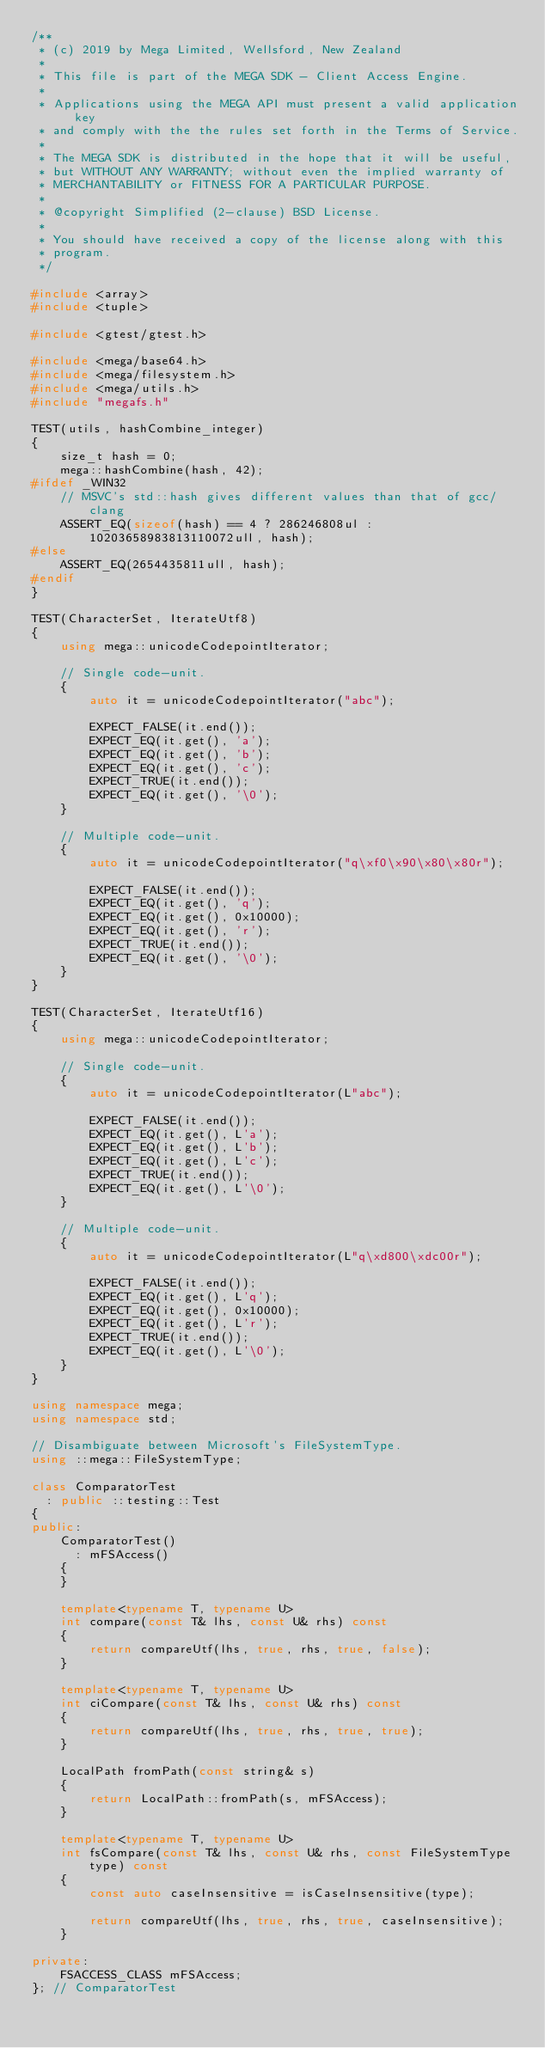Convert code to text. <code><loc_0><loc_0><loc_500><loc_500><_C++_>/**
 * (c) 2019 by Mega Limited, Wellsford, New Zealand
 *
 * This file is part of the MEGA SDK - Client Access Engine.
 *
 * Applications using the MEGA API must present a valid application key
 * and comply with the the rules set forth in the Terms of Service.
 *
 * The MEGA SDK is distributed in the hope that it will be useful,
 * but WITHOUT ANY WARRANTY; without even the implied warranty of
 * MERCHANTABILITY or FITNESS FOR A PARTICULAR PURPOSE.
 *
 * @copyright Simplified (2-clause) BSD License.
 *
 * You should have received a copy of the license along with this
 * program.
 */

#include <array>
#include <tuple>

#include <gtest/gtest.h>

#include <mega/base64.h>
#include <mega/filesystem.h>
#include <mega/utils.h>
#include "megafs.h"

TEST(utils, hashCombine_integer)
{
    size_t hash = 0;
    mega::hashCombine(hash, 42);
#ifdef _WIN32
    // MSVC's std::hash gives different values than that of gcc/clang
    ASSERT_EQ(sizeof(hash) == 4 ? 286246808ul : 10203658983813110072ull, hash);
#else
    ASSERT_EQ(2654435811ull, hash);
#endif
}

TEST(CharacterSet, IterateUtf8)
{
    using mega::unicodeCodepointIterator;

    // Single code-unit.
    {
        auto it = unicodeCodepointIterator("abc");

        EXPECT_FALSE(it.end());
        EXPECT_EQ(it.get(), 'a');
        EXPECT_EQ(it.get(), 'b');
        EXPECT_EQ(it.get(), 'c');
        EXPECT_TRUE(it.end());
        EXPECT_EQ(it.get(), '\0');
    }

    // Multiple code-unit.
    {
        auto it = unicodeCodepointIterator("q\xf0\x90\x80\x80r");

        EXPECT_FALSE(it.end());
        EXPECT_EQ(it.get(), 'q');
        EXPECT_EQ(it.get(), 0x10000);
        EXPECT_EQ(it.get(), 'r');
        EXPECT_TRUE(it.end());
        EXPECT_EQ(it.get(), '\0');
    }
}

TEST(CharacterSet, IterateUtf16)
{
    using mega::unicodeCodepointIterator;

    // Single code-unit.
    {
        auto it = unicodeCodepointIterator(L"abc");

        EXPECT_FALSE(it.end());
        EXPECT_EQ(it.get(), L'a');
        EXPECT_EQ(it.get(), L'b');
        EXPECT_EQ(it.get(), L'c');
        EXPECT_TRUE(it.end());
        EXPECT_EQ(it.get(), L'\0');
    }

    // Multiple code-unit.
    {
        auto it = unicodeCodepointIterator(L"q\xd800\xdc00r");

        EXPECT_FALSE(it.end());
        EXPECT_EQ(it.get(), L'q');
        EXPECT_EQ(it.get(), 0x10000);
        EXPECT_EQ(it.get(), L'r');
        EXPECT_TRUE(it.end());
        EXPECT_EQ(it.get(), L'\0');
    }
}

using namespace mega;
using namespace std;

// Disambiguate between Microsoft's FileSystemType.
using ::mega::FileSystemType;

class ComparatorTest
  : public ::testing::Test
{
public:
    ComparatorTest()
      : mFSAccess()
    {
    }

    template<typename T, typename U>
    int compare(const T& lhs, const U& rhs) const
    {
        return compareUtf(lhs, true, rhs, true, false);
    }

    template<typename T, typename U>
    int ciCompare(const T& lhs, const U& rhs) const
    {
        return compareUtf(lhs, true, rhs, true, true);
    }

    LocalPath fromPath(const string& s)
    {
        return LocalPath::fromPath(s, mFSAccess);
    }

    template<typename T, typename U>
    int fsCompare(const T& lhs, const U& rhs, const FileSystemType type) const
    {
        const auto caseInsensitive = isCaseInsensitive(type);

        return compareUtf(lhs, true, rhs, true, caseInsensitive);
    }

private:
    FSACCESS_CLASS mFSAccess;
}; // ComparatorTest
</code> 